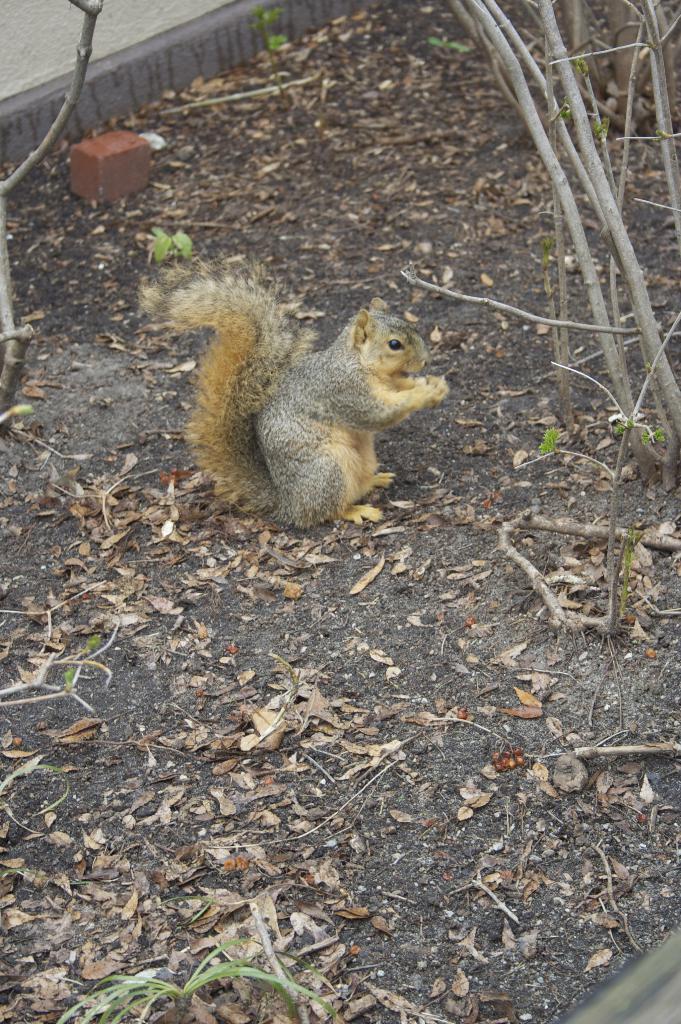Please provide a concise description of this image. There is a squirrel in the center of the image, there are dry leaves and stems around the area. 